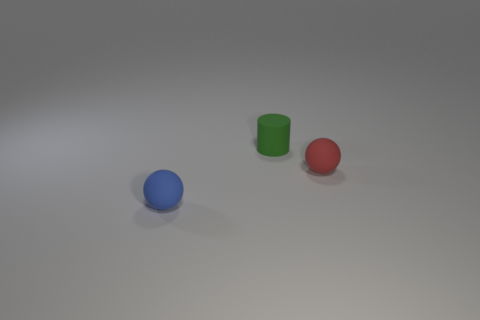Is the number of green matte objects that are behind the red matte object greater than the number of small cylinders that are behind the small green rubber object?
Provide a succinct answer. Yes. How many matte objects are either tiny blue spheres or big red objects?
Give a very brief answer. 1. How many objects are either big blue matte cubes or small spheres right of the small green cylinder?
Offer a terse response. 1. The red object that is the same size as the blue rubber ball is what shape?
Your answer should be very brief. Sphere. What shape is the small blue matte thing?
Your answer should be very brief. Sphere. How many red objects are rubber spheres or big metal cylinders?
Ensure brevity in your answer.  1. What number of other things are the same material as the red sphere?
Ensure brevity in your answer.  2. Do the thing right of the tiny green matte object and the blue thing have the same shape?
Offer a terse response. Yes. Are any big cyan rubber spheres visible?
Make the answer very short. No. Are there any other things that are the same shape as the green rubber object?
Your answer should be very brief. No. 